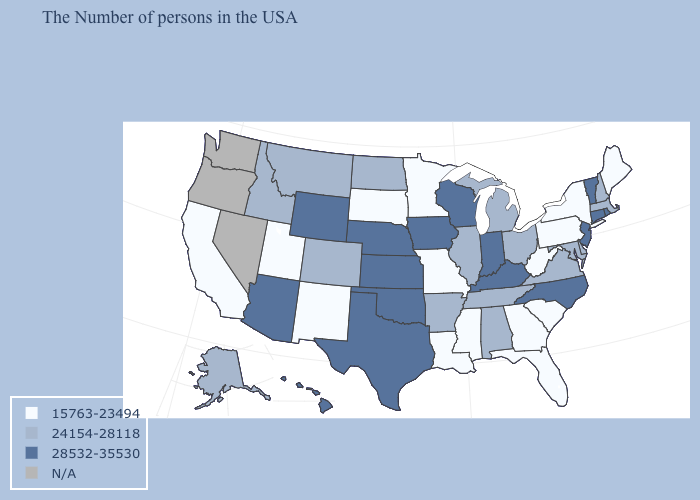Is the legend a continuous bar?
Be succinct. No. Among the states that border Wyoming , which have the highest value?
Answer briefly. Nebraska. Name the states that have a value in the range 15763-23494?
Quick response, please. Maine, New York, Pennsylvania, South Carolina, West Virginia, Florida, Georgia, Mississippi, Louisiana, Missouri, Minnesota, South Dakota, New Mexico, Utah, California. What is the value of Nebraska?
Concise answer only. 28532-35530. Name the states that have a value in the range 28532-35530?
Concise answer only. Rhode Island, Vermont, Connecticut, New Jersey, North Carolina, Kentucky, Indiana, Wisconsin, Iowa, Kansas, Nebraska, Oklahoma, Texas, Wyoming, Arizona, Hawaii. Among the states that border Tennessee , which have the highest value?
Quick response, please. North Carolina, Kentucky. Which states have the lowest value in the Northeast?
Concise answer only. Maine, New York, Pennsylvania. Which states have the lowest value in the USA?
Concise answer only. Maine, New York, Pennsylvania, South Carolina, West Virginia, Florida, Georgia, Mississippi, Louisiana, Missouri, Minnesota, South Dakota, New Mexico, Utah, California. Name the states that have a value in the range N/A?
Concise answer only. Nevada, Washington, Oregon. Name the states that have a value in the range N/A?
Be succinct. Nevada, Washington, Oregon. What is the value of Wisconsin?
Concise answer only. 28532-35530. What is the value of Iowa?
Write a very short answer. 28532-35530. What is the lowest value in the USA?
Quick response, please. 15763-23494. 